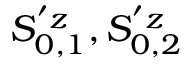Convert formula to latex. <formula><loc_0><loc_0><loc_500><loc_500>S _ { 0 , 1 } ^ { ^ { \prime } z } , S _ { 0 , 2 } ^ { ^ { \prime } z }</formula> 